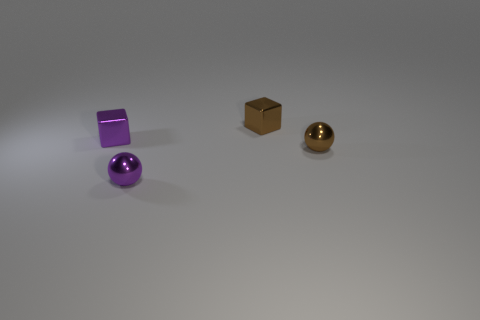How many blocks are small cyan objects or small things?
Make the answer very short. 2. The other tiny cube that is the same material as the small brown block is what color?
Offer a terse response. Purple. There is a shiny sphere that is on the left side of the brown block; is it the same size as the tiny purple cube?
Your answer should be very brief. Yes. Do the purple block and the tiny ball on the right side of the purple ball have the same material?
Keep it short and to the point. Yes. There is a thing to the left of the purple ball; what is its color?
Your answer should be compact. Purple. There is a tiny object to the right of the tiny brown cube; is there a small purple metallic block that is behind it?
Provide a short and direct response. Yes. There is a sphere that is on the left side of the tiny brown shiny sphere; is its color the same as the thing behind the small purple block?
Offer a very short reply. No. There is a small purple ball; what number of tiny brown objects are to the left of it?
Keep it short and to the point. 0. Do the small cube that is on the left side of the brown metal cube and the tiny purple ball have the same material?
Make the answer very short. Yes. How many red things are made of the same material as the brown ball?
Offer a terse response. 0. 